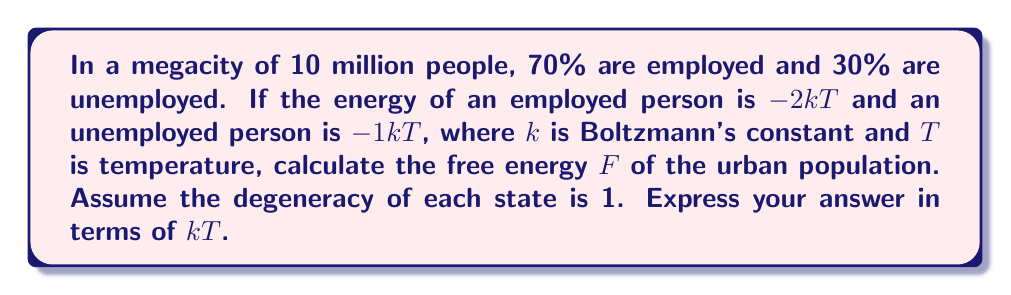Show me your answer to this math problem. To solve this problem, we'll use the canonical ensemble formulation of statistical mechanics. The free energy F is given by:

$$F = -kT \ln Z$$

where Z is the partition function.

Step 1: Calculate the partition function Z
The partition function for a system with multiple states is:

$$Z = \sum_i g_i e^{-\beta E_i}$$

where $g_i$ is the degeneracy of state i, $\beta = \frac{1}{kT}$, and $E_i$ is the energy of state i.

In this case:
- Employed state: $g_1 = 1$, $E_1 = -2kT$, population = 7 million
- Unemployed state: $g_2 = 1$, $E_2 = -1kT$, population = 3 million

$$Z = 7 \times 10^6 \cdot 1 \cdot e^{2} + 3 \times 10^6 \cdot 1 \cdot e^{1}$$

Step 2: Simplify the partition function
$$Z = 7 \times 10^6 \cdot e^2 + 3 \times 10^6 \cdot e$$

Step 3: Calculate the free energy
$$F = -kT \ln(7 \times 10^6 \cdot e^2 + 3 \times 10^6 \cdot e)$$

Step 4: Simplify
$$F = -kT \ln(7e^2 + 3e) \times 10^6$$
$$F = -kT [\ln(7e^2 + 3e) + \ln(10^6)]$$
$$F = -kT [\ln(7e^2 + 3e) + 6 \ln(10)]$$
Answer: $F = -kT [\ln(7e^2 + 3e) + 6 \ln(10)]$ 